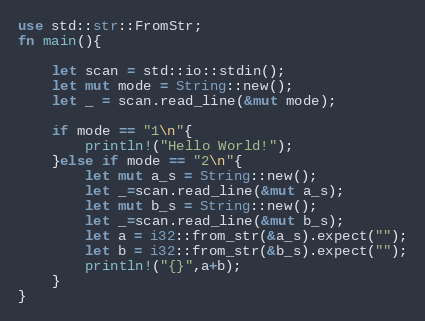<code> <loc_0><loc_0><loc_500><loc_500><_Rust_>use std::str::FromStr;
fn main(){
    
    let scan = std::io::stdin();
    let mut mode = String::new();
    let _ = scan.read_line(&mut mode);

    if mode == "1\n"{
        println!("Hello World!");
    }else if mode == "2\n"{
        let mut a_s = String::new();
        let _=scan.read_line(&mut a_s);
        let mut b_s = String::new();
        let _=scan.read_line(&mut b_s);
        let a = i32::from_str(&a_s).expect("");
        let b = i32::from_str(&b_s).expect("");
        println!("{}",a+b);
    }
}</code> 